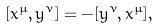<formula> <loc_0><loc_0><loc_500><loc_500>[ x ^ { \mu } , y ^ { \nu } ] = - [ y ^ { \nu } , x ^ { \mu } ] ,</formula> 